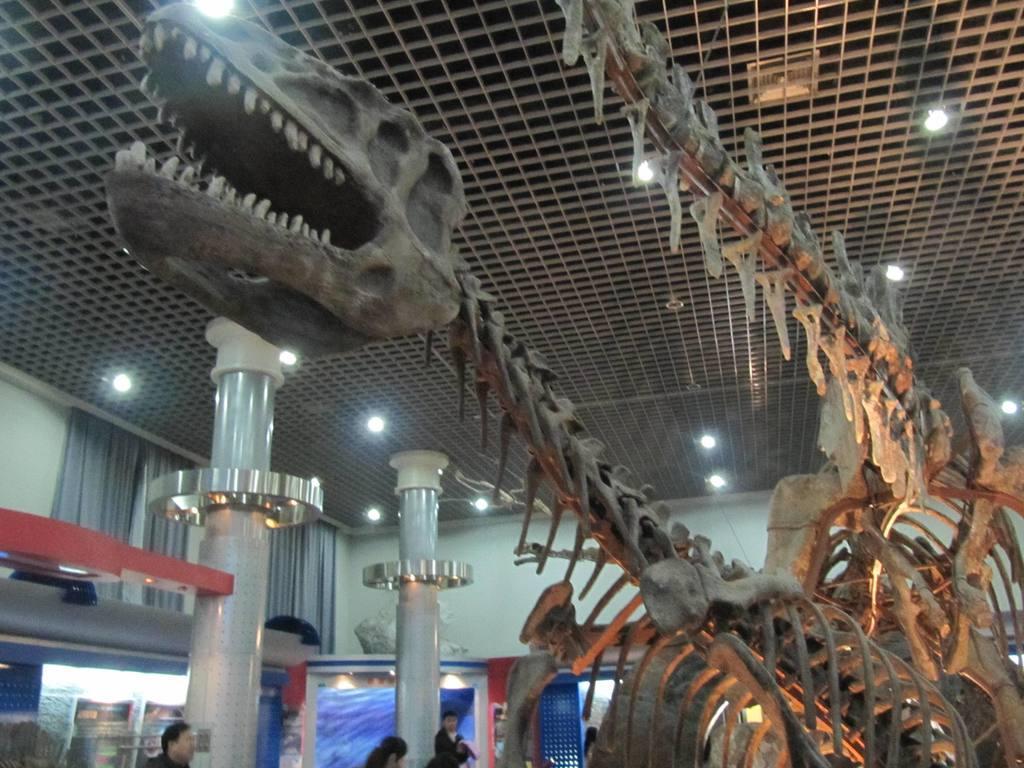Could you give a brief overview of what you see in this image? In this image we can see the skeletons of the animals, there are some pillars, people, curtains, posters and the wall, at the top we can see some lights. 